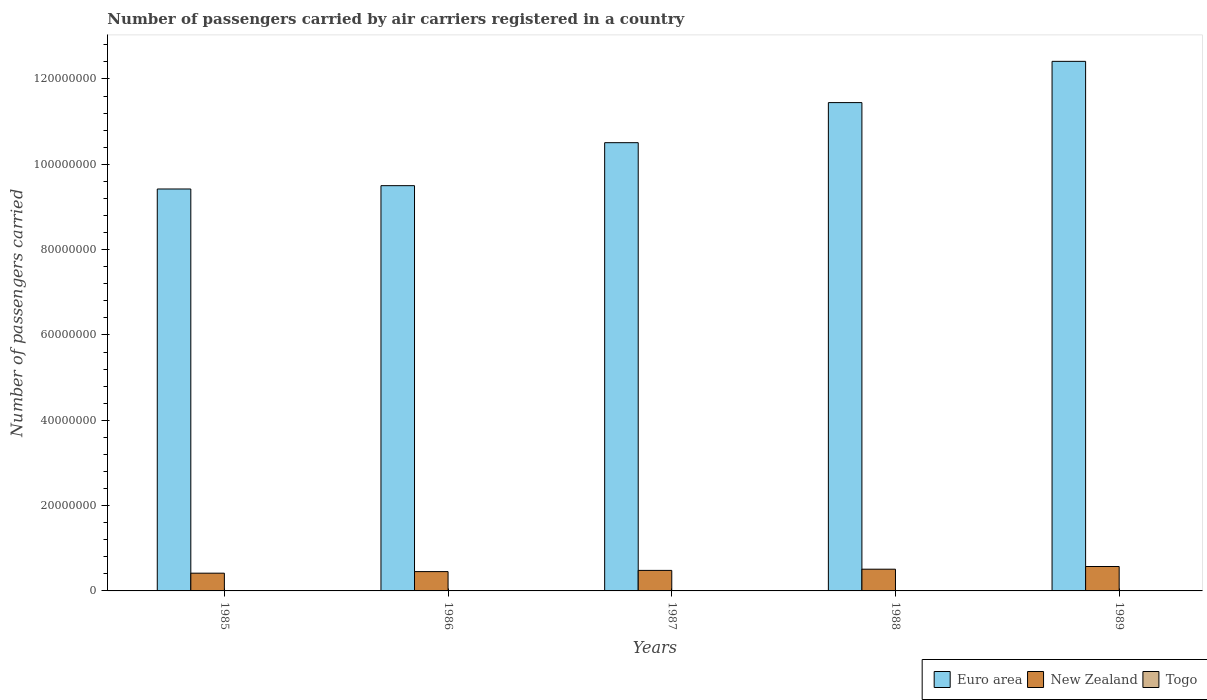How many different coloured bars are there?
Your response must be concise. 3. Are the number of bars per tick equal to the number of legend labels?
Provide a short and direct response. Yes. In how many cases, is the number of bars for a given year not equal to the number of legend labels?
Your response must be concise. 0. What is the number of passengers carried by air carriers in Togo in 1986?
Offer a terse response. 7.84e+04. Across all years, what is the maximum number of passengers carried by air carriers in New Zealand?
Offer a very short reply. 5.72e+06. Across all years, what is the minimum number of passengers carried by air carriers in New Zealand?
Make the answer very short. 4.16e+06. In which year was the number of passengers carried by air carriers in Euro area maximum?
Your answer should be very brief. 1989. In which year was the number of passengers carried by air carriers in New Zealand minimum?
Your response must be concise. 1985. What is the total number of passengers carried by air carriers in Euro area in the graph?
Your answer should be compact. 5.33e+08. What is the difference between the number of passengers carried by air carriers in Togo in 1985 and that in 1989?
Keep it short and to the point. 3500. What is the difference between the number of passengers carried by air carriers in New Zealand in 1987 and the number of passengers carried by air carriers in Euro area in 1989?
Offer a very short reply. -1.19e+08. What is the average number of passengers carried by air carriers in Euro area per year?
Keep it short and to the point. 1.07e+08. In the year 1989, what is the difference between the number of passengers carried by air carriers in Togo and number of passengers carried by air carriers in New Zealand?
Provide a succinct answer. -5.65e+06. What is the ratio of the number of passengers carried by air carriers in New Zealand in 1985 to that in 1987?
Keep it short and to the point. 0.86. Is the difference between the number of passengers carried by air carriers in Togo in 1987 and 1988 greater than the difference between the number of passengers carried by air carriers in New Zealand in 1987 and 1988?
Your answer should be compact. Yes. What is the difference between the highest and the second highest number of passengers carried by air carriers in New Zealand?
Provide a short and direct response. 6.30e+05. What is the difference between the highest and the lowest number of passengers carried by air carriers in New Zealand?
Offer a terse response. 1.56e+06. In how many years, is the number of passengers carried by air carriers in New Zealand greater than the average number of passengers carried by air carriers in New Zealand taken over all years?
Your answer should be very brief. 2. Is the sum of the number of passengers carried by air carriers in Euro area in 1987 and 1988 greater than the maximum number of passengers carried by air carriers in Togo across all years?
Ensure brevity in your answer.  Yes. What does the 3rd bar from the left in 1988 represents?
Your response must be concise. Togo. What does the 2nd bar from the right in 1987 represents?
Offer a very short reply. New Zealand. Is it the case that in every year, the sum of the number of passengers carried by air carriers in Euro area and number of passengers carried by air carriers in New Zealand is greater than the number of passengers carried by air carriers in Togo?
Your answer should be very brief. Yes. How many years are there in the graph?
Your answer should be very brief. 5. Does the graph contain grids?
Provide a short and direct response. No. Where does the legend appear in the graph?
Provide a succinct answer. Bottom right. How many legend labels are there?
Offer a terse response. 3. How are the legend labels stacked?
Offer a very short reply. Horizontal. What is the title of the graph?
Provide a succinct answer. Number of passengers carried by air carriers registered in a country. Does "Germany" appear as one of the legend labels in the graph?
Give a very brief answer. No. What is the label or title of the X-axis?
Your response must be concise. Years. What is the label or title of the Y-axis?
Provide a short and direct response. Number of passengers carried. What is the Number of passengers carried in Euro area in 1985?
Give a very brief answer. 9.42e+07. What is the Number of passengers carried of New Zealand in 1985?
Make the answer very short. 4.16e+06. What is the Number of passengers carried in Togo in 1985?
Give a very brief answer. 7.75e+04. What is the Number of passengers carried of Euro area in 1986?
Ensure brevity in your answer.  9.50e+07. What is the Number of passengers carried of New Zealand in 1986?
Ensure brevity in your answer.  4.53e+06. What is the Number of passengers carried in Togo in 1986?
Offer a terse response. 7.84e+04. What is the Number of passengers carried of Euro area in 1987?
Offer a very short reply. 1.05e+08. What is the Number of passengers carried of New Zealand in 1987?
Make the answer very short. 4.81e+06. What is the Number of passengers carried of Togo in 1987?
Your answer should be compact. 7.01e+04. What is the Number of passengers carried of Euro area in 1988?
Ensure brevity in your answer.  1.14e+08. What is the Number of passengers carried of New Zealand in 1988?
Provide a short and direct response. 5.09e+06. What is the Number of passengers carried in Togo in 1988?
Offer a terse response. 6.97e+04. What is the Number of passengers carried in Euro area in 1989?
Keep it short and to the point. 1.24e+08. What is the Number of passengers carried of New Zealand in 1989?
Ensure brevity in your answer.  5.72e+06. What is the Number of passengers carried in Togo in 1989?
Your response must be concise. 7.40e+04. Across all years, what is the maximum Number of passengers carried in Euro area?
Give a very brief answer. 1.24e+08. Across all years, what is the maximum Number of passengers carried in New Zealand?
Provide a short and direct response. 5.72e+06. Across all years, what is the maximum Number of passengers carried of Togo?
Give a very brief answer. 7.84e+04. Across all years, what is the minimum Number of passengers carried of Euro area?
Make the answer very short. 9.42e+07. Across all years, what is the minimum Number of passengers carried of New Zealand?
Keep it short and to the point. 4.16e+06. Across all years, what is the minimum Number of passengers carried in Togo?
Keep it short and to the point. 6.97e+04. What is the total Number of passengers carried of Euro area in the graph?
Offer a terse response. 5.33e+08. What is the total Number of passengers carried in New Zealand in the graph?
Ensure brevity in your answer.  2.43e+07. What is the total Number of passengers carried in Togo in the graph?
Keep it short and to the point. 3.70e+05. What is the difference between the Number of passengers carried of Euro area in 1985 and that in 1986?
Your answer should be very brief. -7.80e+05. What is the difference between the Number of passengers carried in New Zealand in 1985 and that in 1986?
Keep it short and to the point. -3.69e+05. What is the difference between the Number of passengers carried in Togo in 1985 and that in 1986?
Your answer should be compact. -900. What is the difference between the Number of passengers carried of Euro area in 1985 and that in 1987?
Your answer should be compact. -1.09e+07. What is the difference between the Number of passengers carried in New Zealand in 1985 and that in 1987?
Your answer should be very brief. -6.54e+05. What is the difference between the Number of passengers carried in Togo in 1985 and that in 1987?
Your answer should be compact. 7400. What is the difference between the Number of passengers carried of Euro area in 1985 and that in 1988?
Your answer should be very brief. -2.02e+07. What is the difference between the Number of passengers carried in New Zealand in 1985 and that in 1988?
Offer a terse response. -9.35e+05. What is the difference between the Number of passengers carried of Togo in 1985 and that in 1988?
Give a very brief answer. 7800. What is the difference between the Number of passengers carried in Euro area in 1985 and that in 1989?
Ensure brevity in your answer.  -2.99e+07. What is the difference between the Number of passengers carried in New Zealand in 1985 and that in 1989?
Keep it short and to the point. -1.56e+06. What is the difference between the Number of passengers carried in Togo in 1985 and that in 1989?
Your answer should be compact. 3500. What is the difference between the Number of passengers carried of Euro area in 1986 and that in 1987?
Keep it short and to the point. -1.01e+07. What is the difference between the Number of passengers carried in New Zealand in 1986 and that in 1987?
Make the answer very short. -2.85e+05. What is the difference between the Number of passengers carried of Togo in 1986 and that in 1987?
Provide a short and direct response. 8300. What is the difference between the Number of passengers carried of Euro area in 1986 and that in 1988?
Provide a succinct answer. -1.95e+07. What is the difference between the Number of passengers carried of New Zealand in 1986 and that in 1988?
Provide a succinct answer. -5.66e+05. What is the difference between the Number of passengers carried of Togo in 1986 and that in 1988?
Keep it short and to the point. 8700. What is the difference between the Number of passengers carried in Euro area in 1986 and that in 1989?
Make the answer very short. -2.91e+07. What is the difference between the Number of passengers carried in New Zealand in 1986 and that in 1989?
Provide a short and direct response. -1.20e+06. What is the difference between the Number of passengers carried in Togo in 1986 and that in 1989?
Your answer should be very brief. 4400. What is the difference between the Number of passengers carried in Euro area in 1987 and that in 1988?
Provide a short and direct response. -9.39e+06. What is the difference between the Number of passengers carried in New Zealand in 1987 and that in 1988?
Your answer should be very brief. -2.81e+05. What is the difference between the Number of passengers carried in Togo in 1987 and that in 1988?
Make the answer very short. 400. What is the difference between the Number of passengers carried of Euro area in 1987 and that in 1989?
Offer a very short reply. -1.91e+07. What is the difference between the Number of passengers carried of New Zealand in 1987 and that in 1989?
Your response must be concise. -9.11e+05. What is the difference between the Number of passengers carried in Togo in 1987 and that in 1989?
Offer a terse response. -3900. What is the difference between the Number of passengers carried in Euro area in 1988 and that in 1989?
Keep it short and to the point. -9.67e+06. What is the difference between the Number of passengers carried of New Zealand in 1988 and that in 1989?
Give a very brief answer. -6.30e+05. What is the difference between the Number of passengers carried of Togo in 1988 and that in 1989?
Provide a succinct answer. -4300. What is the difference between the Number of passengers carried of Euro area in 1985 and the Number of passengers carried of New Zealand in 1986?
Your response must be concise. 8.97e+07. What is the difference between the Number of passengers carried in Euro area in 1985 and the Number of passengers carried in Togo in 1986?
Provide a short and direct response. 9.41e+07. What is the difference between the Number of passengers carried in New Zealand in 1985 and the Number of passengers carried in Togo in 1986?
Your answer should be compact. 4.08e+06. What is the difference between the Number of passengers carried in Euro area in 1985 and the Number of passengers carried in New Zealand in 1987?
Provide a short and direct response. 8.94e+07. What is the difference between the Number of passengers carried of Euro area in 1985 and the Number of passengers carried of Togo in 1987?
Offer a very short reply. 9.41e+07. What is the difference between the Number of passengers carried in New Zealand in 1985 and the Number of passengers carried in Togo in 1987?
Offer a very short reply. 4.09e+06. What is the difference between the Number of passengers carried in Euro area in 1985 and the Number of passengers carried in New Zealand in 1988?
Your answer should be compact. 8.91e+07. What is the difference between the Number of passengers carried of Euro area in 1985 and the Number of passengers carried of Togo in 1988?
Ensure brevity in your answer.  9.41e+07. What is the difference between the Number of passengers carried in New Zealand in 1985 and the Number of passengers carried in Togo in 1988?
Ensure brevity in your answer.  4.09e+06. What is the difference between the Number of passengers carried of Euro area in 1985 and the Number of passengers carried of New Zealand in 1989?
Your answer should be very brief. 8.85e+07. What is the difference between the Number of passengers carried in Euro area in 1985 and the Number of passengers carried in Togo in 1989?
Offer a very short reply. 9.41e+07. What is the difference between the Number of passengers carried in New Zealand in 1985 and the Number of passengers carried in Togo in 1989?
Offer a terse response. 4.08e+06. What is the difference between the Number of passengers carried of Euro area in 1986 and the Number of passengers carried of New Zealand in 1987?
Your answer should be very brief. 9.02e+07. What is the difference between the Number of passengers carried in Euro area in 1986 and the Number of passengers carried in Togo in 1987?
Offer a very short reply. 9.49e+07. What is the difference between the Number of passengers carried in New Zealand in 1986 and the Number of passengers carried in Togo in 1987?
Your response must be concise. 4.46e+06. What is the difference between the Number of passengers carried of Euro area in 1986 and the Number of passengers carried of New Zealand in 1988?
Ensure brevity in your answer.  8.99e+07. What is the difference between the Number of passengers carried in Euro area in 1986 and the Number of passengers carried in Togo in 1988?
Give a very brief answer. 9.49e+07. What is the difference between the Number of passengers carried in New Zealand in 1986 and the Number of passengers carried in Togo in 1988?
Your answer should be very brief. 4.46e+06. What is the difference between the Number of passengers carried of Euro area in 1986 and the Number of passengers carried of New Zealand in 1989?
Provide a short and direct response. 8.93e+07. What is the difference between the Number of passengers carried of Euro area in 1986 and the Number of passengers carried of Togo in 1989?
Your response must be concise. 9.49e+07. What is the difference between the Number of passengers carried in New Zealand in 1986 and the Number of passengers carried in Togo in 1989?
Provide a succinct answer. 4.45e+06. What is the difference between the Number of passengers carried in Euro area in 1987 and the Number of passengers carried in New Zealand in 1988?
Make the answer very short. 1.00e+08. What is the difference between the Number of passengers carried in Euro area in 1987 and the Number of passengers carried in Togo in 1988?
Offer a very short reply. 1.05e+08. What is the difference between the Number of passengers carried in New Zealand in 1987 and the Number of passengers carried in Togo in 1988?
Offer a terse response. 4.74e+06. What is the difference between the Number of passengers carried in Euro area in 1987 and the Number of passengers carried in New Zealand in 1989?
Your response must be concise. 9.93e+07. What is the difference between the Number of passengers carried of Euro area in 1987 and the Number of passengers carried of Togo in 1989?
Your answer should be compact. 1.05e+08. What is the difference between the Number of passengers carried of New Zealand in 1987 and the Number of passengers carried of Togo in 1989?
Your response must be concise. 4.74e+06. What is the difference between the Number of passengers carried of Euro area in 1988 and the Number of passengers carried of New Zealand in 1989?
Give a very brief answer. 1.09e+08. What is the difference between the Number of passengers carried of Euro area in 1988 and the Number of passengers carried of Togo in 1989?
Provide a short and direct response. 1.14e+08. What is the difference between the Number of passengers carried in New Zealand in 1988 and the Number of passengers carried in Togo in 1989?
Your answer should be very brief. 5.02e+06. What is the average Number of passengers carried in Euro area per year?
Your response must be concise. 1.07e+08. What is the average Number of passengers carried of New Zealand per year?
Offer a terse response. 4.86e+06. What is the average Number of passengers carried in Togo per year?
Offer a very short reply. 7.39e+04. In the year 1985, what is the difference between the Number of passengers carried in Euro area and Number of passengers carried in New Zealand?
Make the answer very short. 9.01e+07. In the year 1985, what is the difference between the Number of passengers carried of Euro area and Number of passengers carried of Togo?
Provide a short and direct response. 9.41e+07. In the year 1985, what is the difference between the Number of passengers carried of New Zealand and Number of passengers carried of Togo?
Offer a very short reply. 4.08e+06. In the year 1986, what is the difference between the Number of passengers carried in Euro area and Number of passengers carried in New Zealand?
Keep it short and to the point. 9.05e+07. In the year 1986, what is the difference between the Number of passengers carried in Euro area and Number of passengers carried in Togo?
Offer a very short reply. 9.49e+07. In the year 1986, what is the difference between the Number of passengers carried in New Zealand and Number of passengers carried in Togo?
Keep it short and to the point. 4.45e+06. In the year 1987, what is the difference between the Number of passengers carried in Euro area and Number of passengers carried in New Zealand?
Provide a succinct answer. 1.00e+08. In the year 1987, what is the difference between the Number of passengers carried of Euro area and Number of passengers carried of Togo?
Your answer should be compact. 1.05e+08. In the year 1987, what is the difference between the Number of passengers carried of New Zealand and Number of passengers carried of Togo?
Keep it short and to the point. 4.74e+06. In the year 1988, what is the difference between the Number of passengers carried in Euro area and Number of passengers carried in New Zealand?
Ensure brevity in your answer.  1.09e+08. In the year 1988, what is the difference between the Number of passengers carried in Euro area and Number of passengers carried in Togo?
Make the answer very short. 1.14e+08. In the year 1988, what is the difference between the Number of passengers carried of New Zealand and Number of passengers carried of Togo?
Give a very brief answer. 5.02e+06. In the year 1989, what is the difference between the Number of passengers carried of Euro area and Number of passengers carried of New Zealand?
Your answer should be compact. 1.18e+08. In the year 1989, what is the difference between the Number of passengers carried in Euro area and Number of passengers carried in Togo?
Your answer should be very brief. 1.24e+08. In the year 1989, what is the difference between the Number of passengers carried in New Zealand and Number of passengers carried in Togo?
Your answer should be compact. 5.65e+06. What is the ratio of the Number of passengers carried of New Zealand in 1985 to that in 1986?
Ensure brevity in your answer.  0.92. What is the ratio of the Number of passengers carried of Togo in 1985 to that in 1986?
Offer a very short reply. 0.99. What is the ratio of the Number of passengers carried in Euro area in 1985 to that in 1987?
Provide a succinct answer. 0.9. What is the ratio of the Number of passengers carried of New Zealand in 1985 to that in 1987?
Ensure brevity in your answer.  0.86. What is the ratio of the Number of passengers carried of Togo in 1985 to that in 1987?
Offer a very short reply. 1.11. What is the ratio of the Number of passengers carried in Euro area in 1985 to that in 1988?
Keep it short and to the point. 0.82. What is the ratio of the Number of passengers carried in New Zealand in 1985 to that in 1988?
Offer a terse response. 0.82. What is the ratio of the Number of passengers carried of Togo in 1985 to that in 1988?
Provide a short and direct response. 1.11. What is the ratio of the Number of passengers carried of Euro area in 1985 to that in 1989?
Your answer should be very brief. 0.76. What is the ratio of the Number of passengers carried in New Zealand in 1985 to that in 1989?
Offer a terse response. 0.73. What is the ratio of the Number of passengers carried in Togo in 1985 to that in 1989?
Keep it short and to the point. 1.05. What is the ratio of the Number of passengers carried in Euro area in 1986 to that in 1987?
Make the answer very short. 0.9. What is the ratio of the Number of passengers carried in New Zealand in 1986 to that in 1987?
Offer a very short reply. 0.94. What is the ratio of the Number of passengers carried in Togo in 1986 to that in 1987?
Give a very brief answer. 1.12. What is the ratio of the Number of passengers carried in Euro area in 1986 to that in 1988?
Your answer should be compact. 0.83. What is the ratio of the Number of passengers carried in New Zealand in 1986 to that in 1988?
Provide a short and direct response. 0.89. What is the ratio of the Number of passengers carried in Togo in 1986 to that in 1988?
Give a very brief answer. 1.12. What is the ratio of the Number of passengers carried in Euro area in 1986 to that in 1989?
Offer a terse response. 0.77. What is the ratio of the Number of passengers carried in New Zealand in 1986 to that in 1989?
Your answer should be very brief. 0.79. What is the ratio of the Number of passengers carried in Togo in 1986 to that in 1989?
Your answer should be compact. 1.06. What is the ratio of the Number of passengers carried of Euro area in 1987 to that in 1988?
Make the answer very short. 0.92. What is the ratio of the Number of passengers carried of New Zealand in 1987 to that in 1988?
Ensure brevity in your answer.  0.94. What is the ratio of the Number of passengers carried of Euro area in 1987 to that in 1989?
Give a very brief answer. 0.85. What is the ratio of the Number of passengers carried of New Zealand in 1987 to that in 1989?
Provide a succinct answer. 0.84. What is the ratio of the Number of passengers carried of Togo in 1987 to that in 1989?
Your answer should be very brief. 0.95. What is the ratio of the Number of passengers carried in Euro area in 1988 to that in 1989?
Give a very brief answer. 0.92. What is the ratio of the Number of passengers carried of New Zealand in 1988 to that in 1989?
Your answer should be very brief. 0.89. What is the ratio of the Number of passengers carried in Togo in 1988 to that in 1989?
Make the answer very short. 0.94. What is the difference between the highest and the second highest Number of passengers carried of Euro area?
Make the answer very short. 9.67e+06. What is the difference between the highest and the second highest Number of passengers carried of New Zealand?
Make the answer very short. 6.30e+05. What is the difference between the highest and the second highest Number of passengers carried in Togo?
Ensure brevity in your answer.  900. What is the difference between the highest and the lowest Number of passengers carried of Euro area?
Provide a succinct answer. 2.99e+07. What is the difference between the highest and the lowest Number of passengers carried of New Zealand?
Offer a terse response. 1.56e+06. What is the difference between the highest and the lowest Number of passengers carried in Togo?
Offer a very short reply. 8700. 